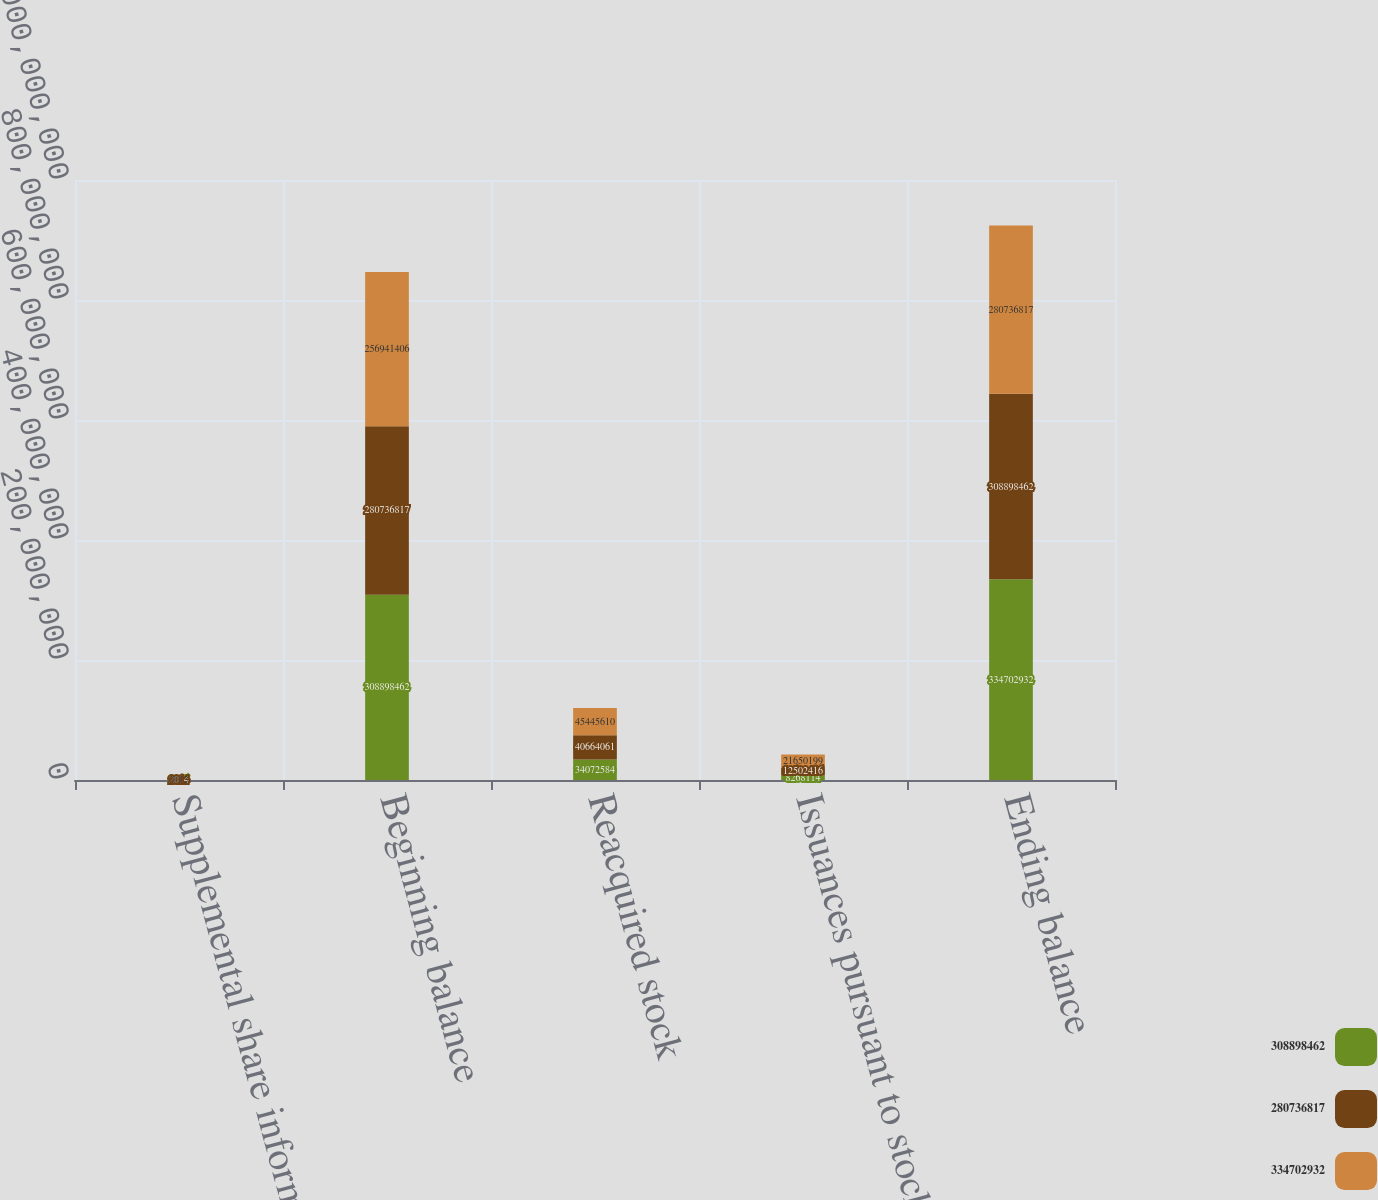<chart> <loc_0><loc_0><loc_500><loc_500><stacked_bar_chart><ecel><fcel>Supplemental share information<fcel>Beginning balance<fcel>Reacquired stock<fcel>Issuances pursuant to stock<fcel>Ending balance<nl><fcel>3.08898e+08<fcel>2015<fcel>3.08898e+08<fcel>3.40726e+07<fcel>8.26811e+06<fcel>3.34703e+08<nl><fcel>2.80737e+08<fcel>2014<fcel>2.80737e+08<fcel>4.06641e+07<fcel>1.25024e+07<fcel>3.08898e+08<nl><fcel>3.34703e+08<fcel>2013<fcel>2.56941e+08<fcel>4.54456e+07<fcel>2.16502e+07<fcel>2.80737e+08<nl></chart> 